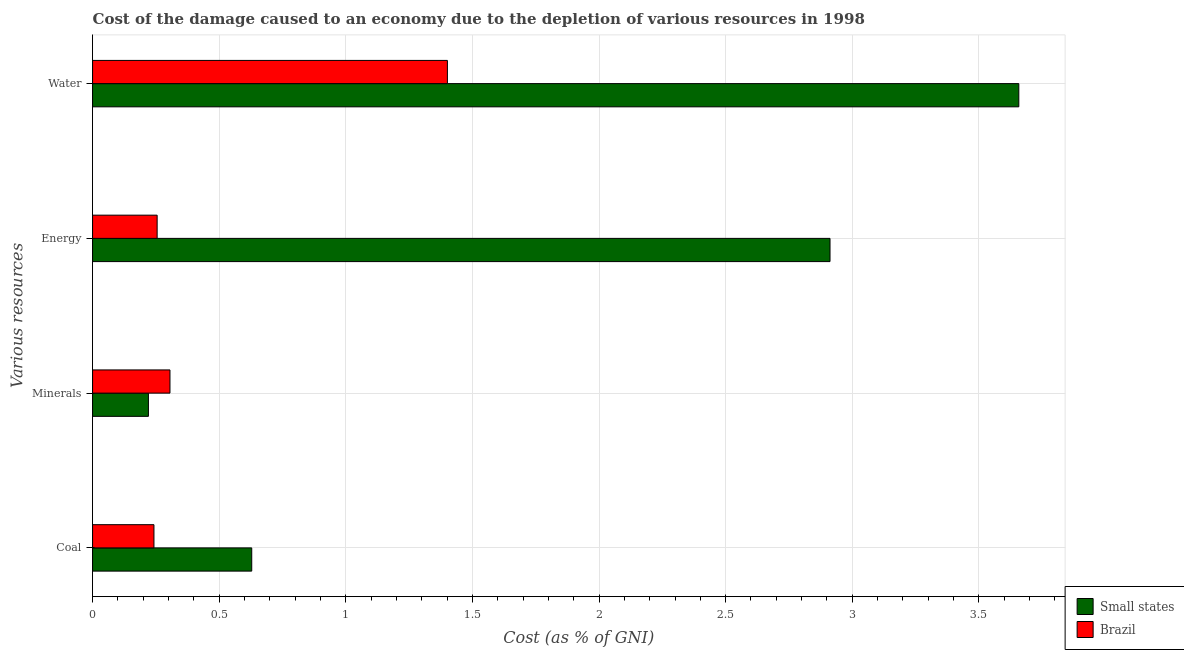How many different coloured bars are there?
Provide a short and direct response. 2. How many groups of bars are there?
Your answer should be very brief. 4. Are the number of bars per tick equal to the number of legend labels?
Your answer should be very brief. Yes. Are the number of bars on each tick of the Y-axis equal?
Your response must be concise. Yes. How many bars are there on the 3rd tick from the top?
Keep it short and to the point. 2. What is the label of the 3rd group of bars from the top?
Offer a very short reply. Minerals. What is the cost of damage due to depletion of water in Brazil?
Your answer should be very brief. 1.4. Across all countries, what is the maximum cost of damage due to depletion of minerals?
Offer a terse response. 0.31. Across all countries, what is the minimum cost of damage due to depletion of energy?
Keep it short and to the point. 0.26. In which country was the cost of damage due to depletion of coal maximum?
Ensure brevity in your answer.  Small states. What is the total cost of damage due to depletion of minerals in the graph?
Offer a very short reply. 0.53. What is the difference between the cost of damage due to depletion of energy in Small states and that in Brazil?
Give a very brief answer. 2.66. What is the difference between the cost of damage due to depletion of coal in Small states and the cost of damage due to depletion of minerals in Brazil?
Provide a succinct answer. 0.32. What is the average cost of damage due to depletion of water per country?
Your response must be concise. 2.53. What is the difference between the cost of damage due to depletion of energy and cost of damage due to depletion of minerals in Small states?
Give a very brief answer. 2.69. In how many countries, is the cost of damage due to depletion of energy greater than 0.7 %?
Keep it short and to the point. 1. What is the ratio of the cost of damage due to depletion of coal in Small states to that in Brazil?
Your answer should be very brief. 2.59. What is the difference between the highest and the second highest cost of damage due to depletion of water?
Provide a succinct answer. 2.26. What is the difference between the highest and the lowest cost of damage due to depletion of minerals?
Give a very brief answer. 0.09. In how many countries, is the cost of damage due to depletion of water greater than the average cost of damage due to depletion of water taken over all countries?
Keep it short and to the point. 1. Is the sum of the cost of damage due to depletion of energy in Small states and Brazil greater than the maximum cost of damage due to depletion of minerals across all countries?
Your response must be concise. Yes. Is it the case that in every country, the sum of the cost of damage due to depletion of energy and cost of damage due to depletion of minerals is greater than the sum of cost of damage due to depletion of water and cost of damage due to depletion of coal?
Ensure brevity in your answer.  Yes. What does the 2nd bar from the top in Energy represents?
Ensure brevity in your answer.  Small states. What does the 1st bar from the bottom in Coal represents?
Ensure brevity in your answer.  Small states. How many countries are there in the graph?
Ensure brevity in your answer.  2. What is the difference between two consecutive major ticks on the X-axis?
Ensure brevity in your answer.  0.5. Are the values on the major ticks of X-axis written in scientific E-notation?
Your answer should be very brief. No. Does the graph contain any zero values?
Provide a short and direct response. No. Where does the legend appear in the graph?
Keep it short and to the point. Bottom right. What is the title of the graph?
Your answer should be very brief. Cost of the damage caused to an economy due to the depletion of various resources in 1998 . What is the label or title of the X-axis?
Make the answer very short. Cost (as % of GNI). What is the label or title of the Y-axis?
Provide a short and direct response. Various resources. What is the Cost (as % of GNI) of Small states in Coal?
Your answer should be compact. 0.63. What is the Cost (as % of GNI) in Brazil in Coal?
Your response must be concise. 0.24. What is the Cost (as % of GNI) of Small states in Minerals?
Your answer should be compact. 0.22. What is the Cost (as % of GNI) in Brazil in Minerals?
Provide a short and direct response. 0.31. What is the Cost (as % of GNI) in Small states in Energy?
Your answer should be compact. 2.91. What is the Cost (as % of GNI) of Brazil in Energy?
Offer a very short reply. 0.26. What is the Cost (as % of GNI) in Small states in Water?
Your answer should be compact. 3.66. What is the Cost (as % of GNI) in Brazil in Water?
Provide a succinct answer. 1.4. Across all Various resources, what is the maximum Cost (as % of GNI) of Small states?
Your answer should be very brief. 3.66. Across all Various resources, what is the maximum Cost (as % of GNI) in Brazil?
Offer a very short reply. 1.4. Across all Various resources, what is the minimum Cost (as % of GNI) of Small states?
Make the answer very short. 0.22. Across all Various resources, what is the minimum Cost (as % of GNI) of Brazil?
Give a very brief answer. 0.24. What is the total Cost (as % of GNI) in Small states in the graph?
Offer a very short reply. 7.42. What is the total Cost (as % of GNI) in Brazil in the graph?
Offer a very short reply. 2.2. What is the difference between the Cost (as % of GNI) of Small states in Coal and that in Minerals?
Your answer should be very brief. 0.41. What is the difference between the Cost (as % of GNI) of Brazil in Coal and that in Minerals?
Make the answer very short. -0.06. What is the difference between the Cost (as % of GNI) of Small states in Coal and that in Energy?
Make the answer very short. -2.28. What is the difference between the Cost (as % of GNI) in Brazil in Coal and that in Energy?
Keep it short and to the point. -0.01. What is the difference between the Cost (as % of GNI) of Small states in Coal and that in Water?
Keep it short and to the point. -3.03. What is the difference between the Cost (as % of GNI) of Brazil in Coal and that in Water?
Your response must be concise. -1.16. What is the difference between the Cost (as % of GNI) in Small states in Minerals and that in Energy?
Ensure brevity in your answer.  -2.69. What is the difference between the Cost (as % of GNI) in Brazil in Minerals and that in Energy?
Your answer should be compact. 0.05. What is the difference between the Cost (as % of GNI) of Small states in Minerals and that in Water?
Provide a short and direct response. -3.44. What is the difference between the Cost (as % of GNI) of Brazil in Minerals and that in Water?
Ensure brevity in your answer.  -1.1. What is the difference between the Cost (as % of GNI) in Small states in Energy and that in Water?
Your answer should be compact. -0.75. What is the difference between the Cost (as % of GNI) in Brazil in Energy and that in Water?
Provide a succinct answer. -1.15. What is the difference between the Cost (as % of GNI) in Small states in Coal and the Cost (as % of GNI) in Brazil in Minerals?
Keep it short and to the point. 0.32. What is the difference between the Cost (as % of GNI) of Small states in Coal and the Cost (as % of GNI) of Brazil in Energy?
Your response must be concise. 0.37. What is the difference between the Cost (as % of GNI) of Small states in Coal and the Cost (as % of GNI) of Brazil in Water?
Keep it short and to the point. -0.77. What is the difference between the Cost (as % of GNI) in Small states in Minerals and the Cost (as % of GNI) in Brazil in Energy?
Your response must be concise. -0.03. What is the difference between the Cost (as % of GNI) of Small states in Minerals and the Cost (as % of GNI) of Brazil in Water?
Your answer should be very brief. -1.18. What is the difference between the Cost (as % of GNI) in Small states in Energy and the Cost (as % of GNI) in Brazil in Water?
Give a very brief answer. 1.51. What is the average Cost (as % of GNI) of Small states per Various resources?
Offer a terse response. 1.85. What is the average Cost (as % of GNI) in Brazil per Various resources?
Give a very brief answer. 0.55. What is the difference between the Cost (as % of GNI) of Small states and Cost (as % of GNI) of Brazil in Coal?
Your answer should be compact. 0.39. What is the difference between the Cost (as % of GNI) of Small states and Cost (as % of GNI) of Brazil in Minerals?
Your response must be concise. -0.09. What is the difference between the Cost (as % of GNI) of Small states and Cost (as % of GNI) of Brazil in Energy?
Ensure brevity in your answer.  2.66. What is the difference between the Cost (as % of GNI) of Small states and Cost (as % of GNI) of Brazil in Water?
Your answer should be very brief. 2.26. What is the ratio of the Cost (as % of GNI) in Small states in Coal to that in Minerals?
Your response must be concise. 2.85. What is the ratio of the Cost (as % of GNI) of Brazil in Coal to that in Minerals?
Your answer should be compact. 0.79. What is the ratio of the Cost (as % of GNI) in Small states in Coal to that in Energy?
Provide a short and direct response. 0.22. What is the ratio of the Cost (as % of GNI) of Brazil in Coal to that in Energy?
Your answer should be compact. 0.95. What is the ratio of the Cost (as % of GNI) in Small states in Coal to that in Water?
Offer a very short reply. 0.17. What is the ratio of the Cost (as % of GNI) of Brazil in Coal to that in Water?
Your response must be concise. 0.17. What is the ratio of the Cost (as % of GNI) of Small states in Minerals to that in Energy?
Your answer should be very brief. 0.08. What is the ratio of the Cost (as % of GNI) of Brazil in Minerals to that in Energy?
Offer a very short reply. 1.2. What is the ratio of the Cost (as % of GNI) in Small states in Minerals to that in Water?
Your answer should be very brief. 0.06. What is the ratio of the Cost (as % of GNI) of Brazil in Minerals to that in Water?
Your answer should be very brief. 0.22. What is the ratio of the Cost (as % of GNI) of Small states in Energy to that in Water?
Keep it short and to the point. 0.8. What is the ratio of the Cost (as % of GNI) of Brazil in Energy to that in Water?
Make the answer very short. 0.18. What is the difference between the highest and the second highest Cost (as % of GNI) in Small states?
Keep it short and to the point. 0.75. What is the difference between the highest and the second highest Cost (as % of GNI) in Brazil?
Give a very brief answer. 1.1. What is the difference between the highest and the lowest Cost (as % of GNI) in Small states?
Offer a very short reply. 3.44. What is the difference between the highest and the lowest Cost (as % of GNI) in Brazil?
Make the answer very short. 1.16. 